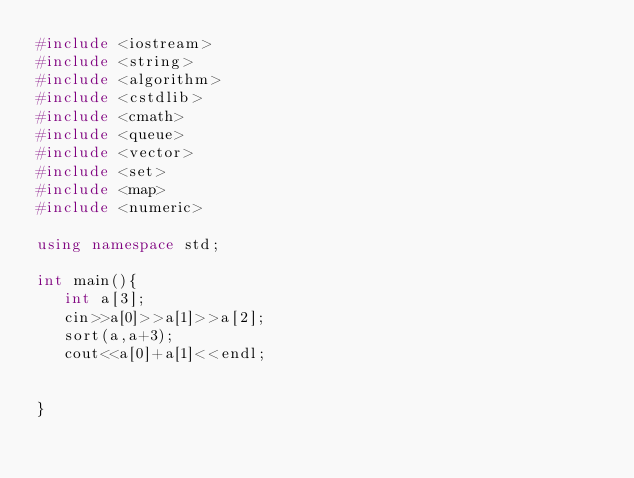<code> <loc_0><loc_0><loc_500><loc_500><_C++_>#include <iostream>
#include <string>
#include <algorithm>
#include <cstdlib>
#include <cmath>
#include <queue>
#include <vector>
#include <set>
#include <map>
#include <numeric>

using namespace std;

int main(){
   int a[3];
   cin>>a[0]>>a[1]>>a[2];
   sort(a,a+3);
   cout<<a[0]+a[1]<<endl;
   
   
}</code> 